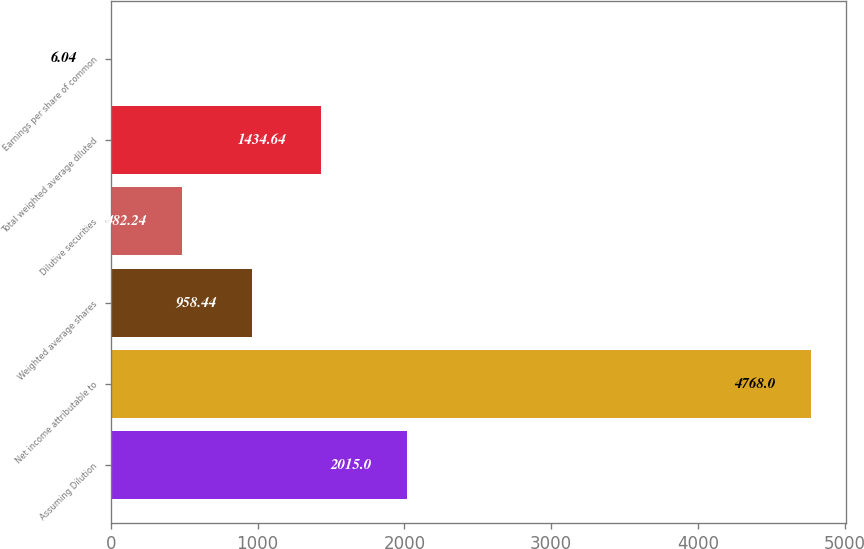Convert chart. <chart><loc_0><loc_0><loc_500><loc_500><bar_chart><fcel>Assuming Dilution<fcel>Net income attributable to<fcel>Weighted average shares<fcel>Dilutive securities<fcel>Total weighted average diluted<fcel>Earnings per share of common<nl><fcel>2015<fcel>4768<fcel>958.44<fcel>482.24<fcel>1434.64<fcel>6.04<nl></chart> 